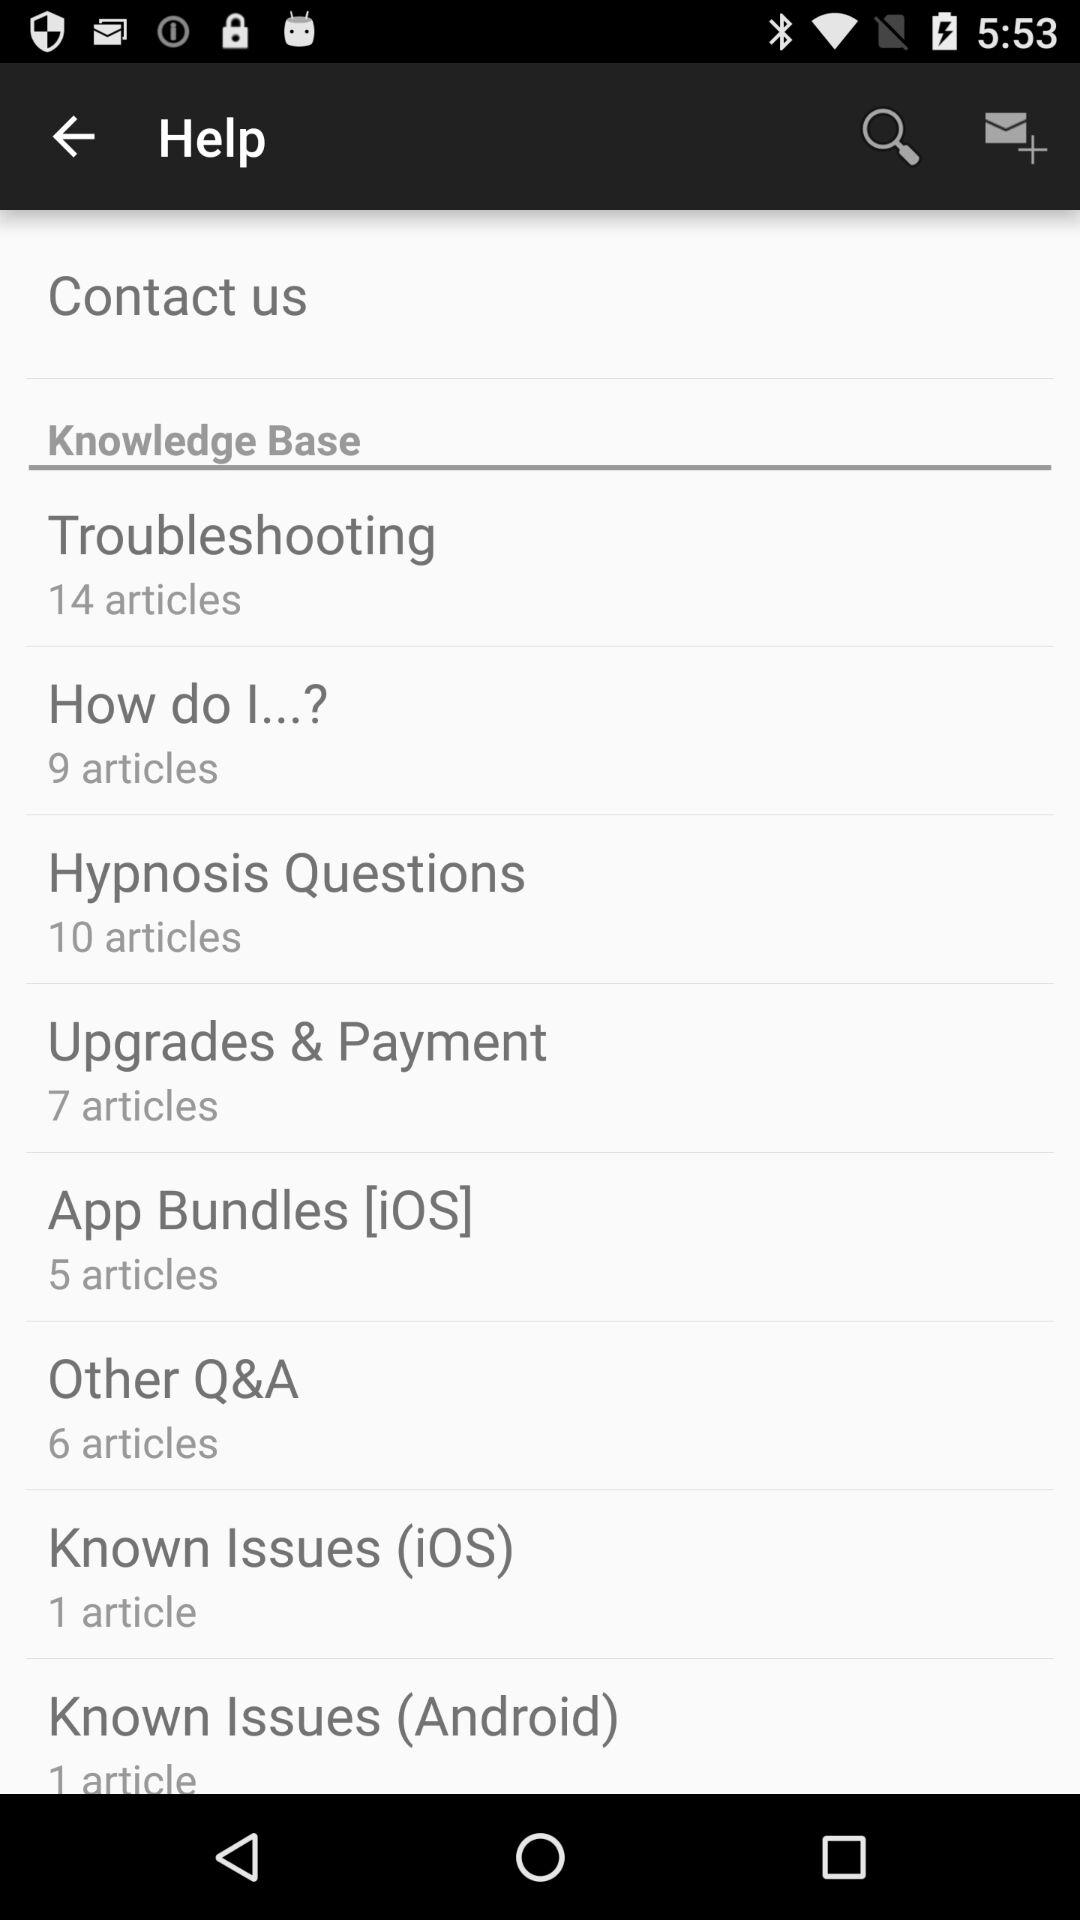How many articles are there in "Troubleshooting"? There are 14 articles in "Troubleshooting". 